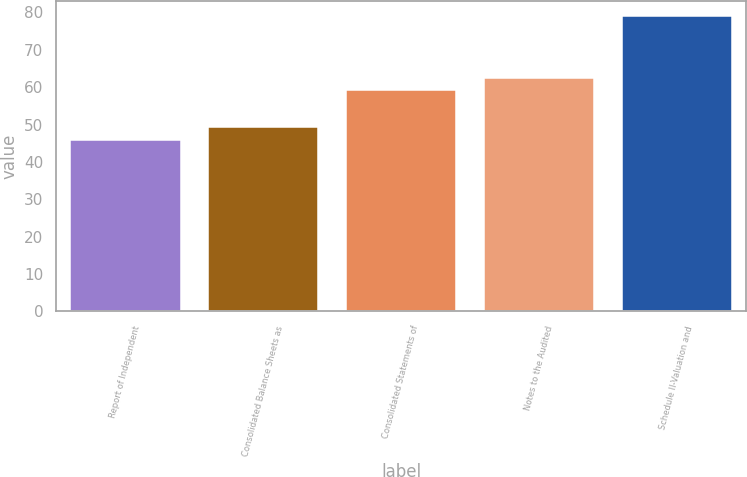<chart> <loc_0><loc_0><loc_500><loc_500><bar_chart><fcel>Report of Independent<fcel>Consolidated Balance Sheets as<fcel>Consolidated Statements of<fcel>Notes to the Audited<fcel>Schedule II-Valuation and<nl><fcel>46<fcel>49.3<fcel>59.2<fcel>62.5<fcel>79<nl></chart> 